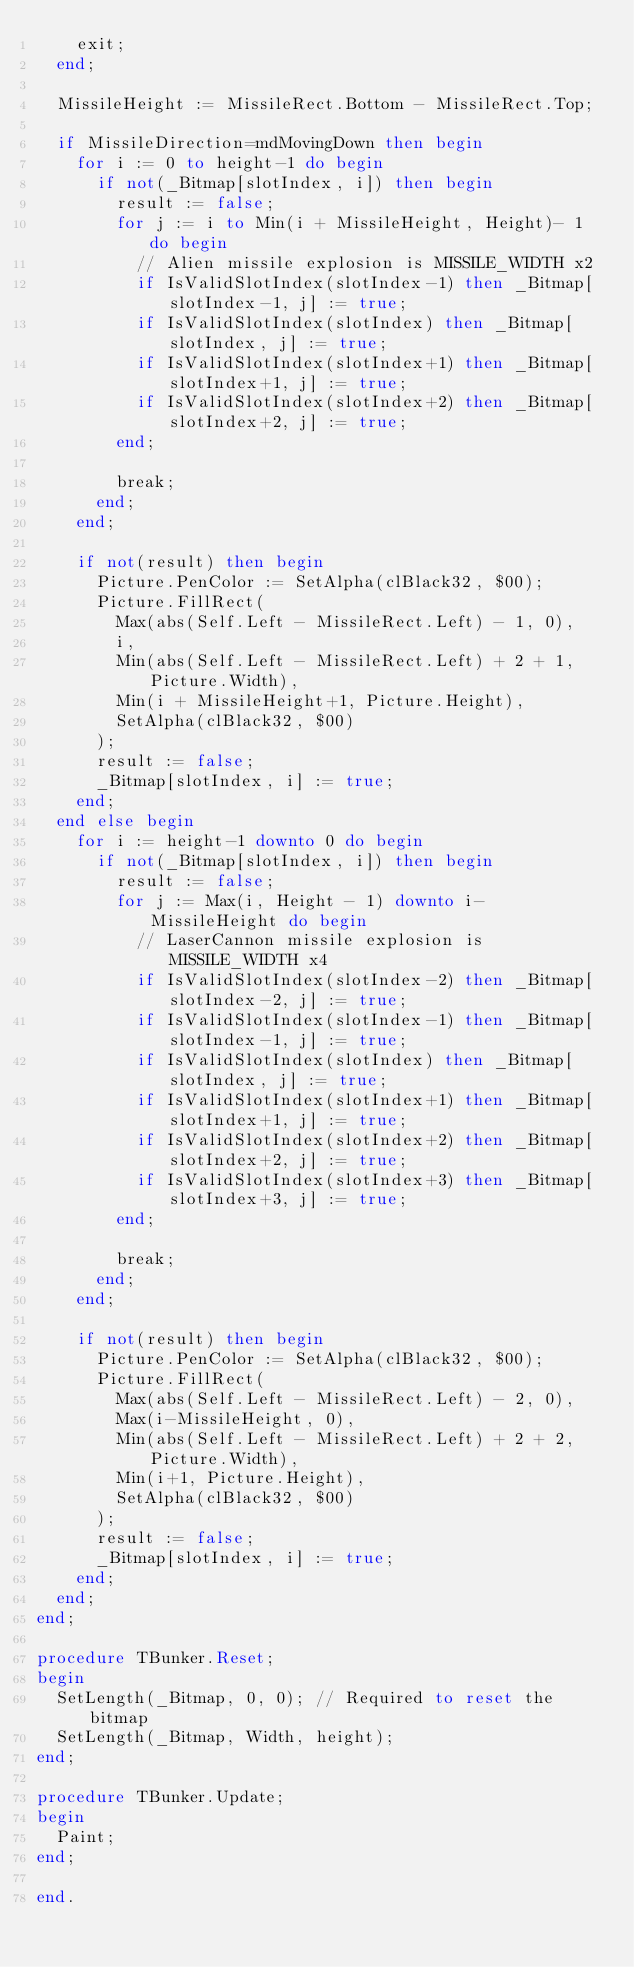<code> <loc_0><loc_0><loc_500><loc_500><_Pascal_>    exit;
  end;

  MissileHeight := MissileRect.Bottom - MissileRect.Top;

  if MissileDirection=mdMovingDown then begin
    for i := 0 to height-1 do begin
      if not(_Bitmap[slotIndex, i]) then begin
        result := false;
        for j := i to Min(i + MissileHeight, Height)- 1 do begin
          // Alien missile explosion is MISSILE_WIDTH x2
          if IsValidSlotIndex(slotIndex-1) then _Bitmap[slotIndex-1, j] := true;
          if IsValidSlotIndex(slotIndex) then _Bitmap[slotIndex, j] := true;
          if IsValidSlotIndex(slotIndex+1) then _Bitmap[slotIndex+1, j] := true;
          if IsValidSlotIndex(slotIndex+2) then _Bitmap[slotIndex+2, j] := true;
        end;

        break;
      end;
    end;

    if not(result) then begin
      Picture.PenColor := SetAlpha(clBlack32, $00);
      Picture.FillRect(
        Max(abs(Self.Left - MissileRect.Left) - 1, 0),
        i,
        Min(abs(Self.Left - MissileRect.Left) + 2 + 1, Picture.Width),
        Min(i + MissileHeight+1, Picture.Height),
        SetAlpha(clBlack32, $00)
      );
      result := false;
      _Bitmap[slotIndex, i] := true;
    end;
  end else begin
    for i := height-1 downto 0 do begin
      if not(_Bitmap[slotIndex, i]) then begin
        result := false;
        for j := Max(i, Height - 1) downto i-MissileHeight do begin
          // LaserCannon missile explosion is MISSILE_WIDTH x4
          if IsValidSlotIndex(slotIndex-2) then _Bitmap[slotIndex-2, j] := true;
          if IsValidSlotIndex(slotIndex-1) then _Bitmap[slotIndex-1, j] := true;
          if IsValidSlotIndex(slotIndex) then _Bitmap[slotIndex, j] := true;
          if IsValidSlotIndex(slotIndex+1) then _Bitmap[slotIndex+1, j] := true;
          if IsValidSlotIndex(slotIndex+2) then _Bitmap[slotIndex+2, j] := true;
          if IsValidSlotIndex(slotIndex+3) then _Bitmap[slotIndex+3, j] := true;
        end;

        break;
      end;
    end;

    if not(result) then begin
      Picture.PenColor := SetAlpha(clBlack32, $00);
      Picture.FillRect(
        Max(abs(Self.Left - MissileRect.Left) - 2, 0),
        Max(i-MissileHeight, 0),
        Min(abs(Self.Left - MissileRect.Left) + 2 + 2, Picture.Width),
        Min(i+1, Picture.Height),
        SetAlpha(clBlack32, $00)
      );
      result := false;
      _Bitmap[slotIndex, i] := true;
    end;
  end;
end;

procedure TBunker.Reset;
begin
  SetLength(_Bitmap, 0, 0); // Required to reset the bitmap
  SetLength(_Bitmap, Width, height);
end;

procedure TBunker.Update;
begin
  Paint;
end;

end.</code> 